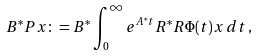Convert formula to latex. <formula><loc_0><loc_0><loc_500><loc_500>B ^ { * } P x \colon = B ^ { * } \int _ { 0 } ^ { \infty } e ^ { A ^ { * } t } R ^ { * } R \Phi ( t ) x \, d t \, ,</formula> 